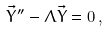Convert formula to latex. <formula><loc_0><loc_0><loc_500><loc_500>\vec { Y } ^ { \prime \prime } - \Lambda \vec { Y } = 0 \, ,</formula> 